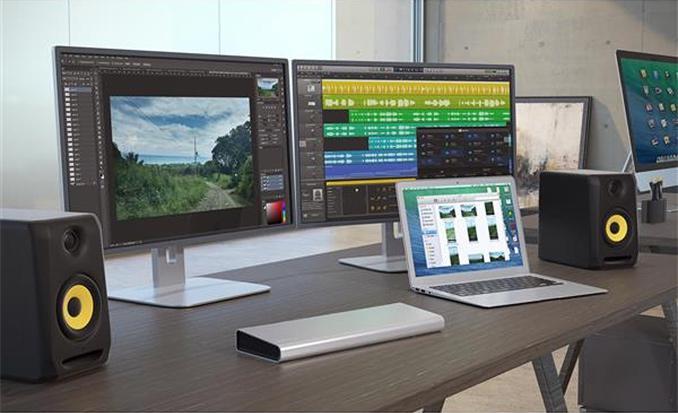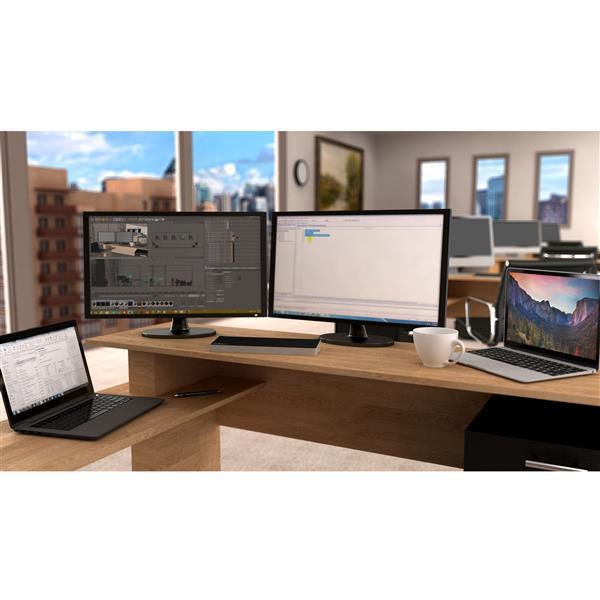The first image is the image on the left, the second image is the image on the right. Given the left and right images, does the statement "The left image shows exactly two open screen devices, one distinctly smaller than the other and positioned next to it on a table." hold true? Answer yes or no. No. The first image is the image on the left, the second image is the image on the right. Analyze the images presented: Is the assertion "Both of the tables under the computers have straight edges." valid? Answer yes or no. Yes. 